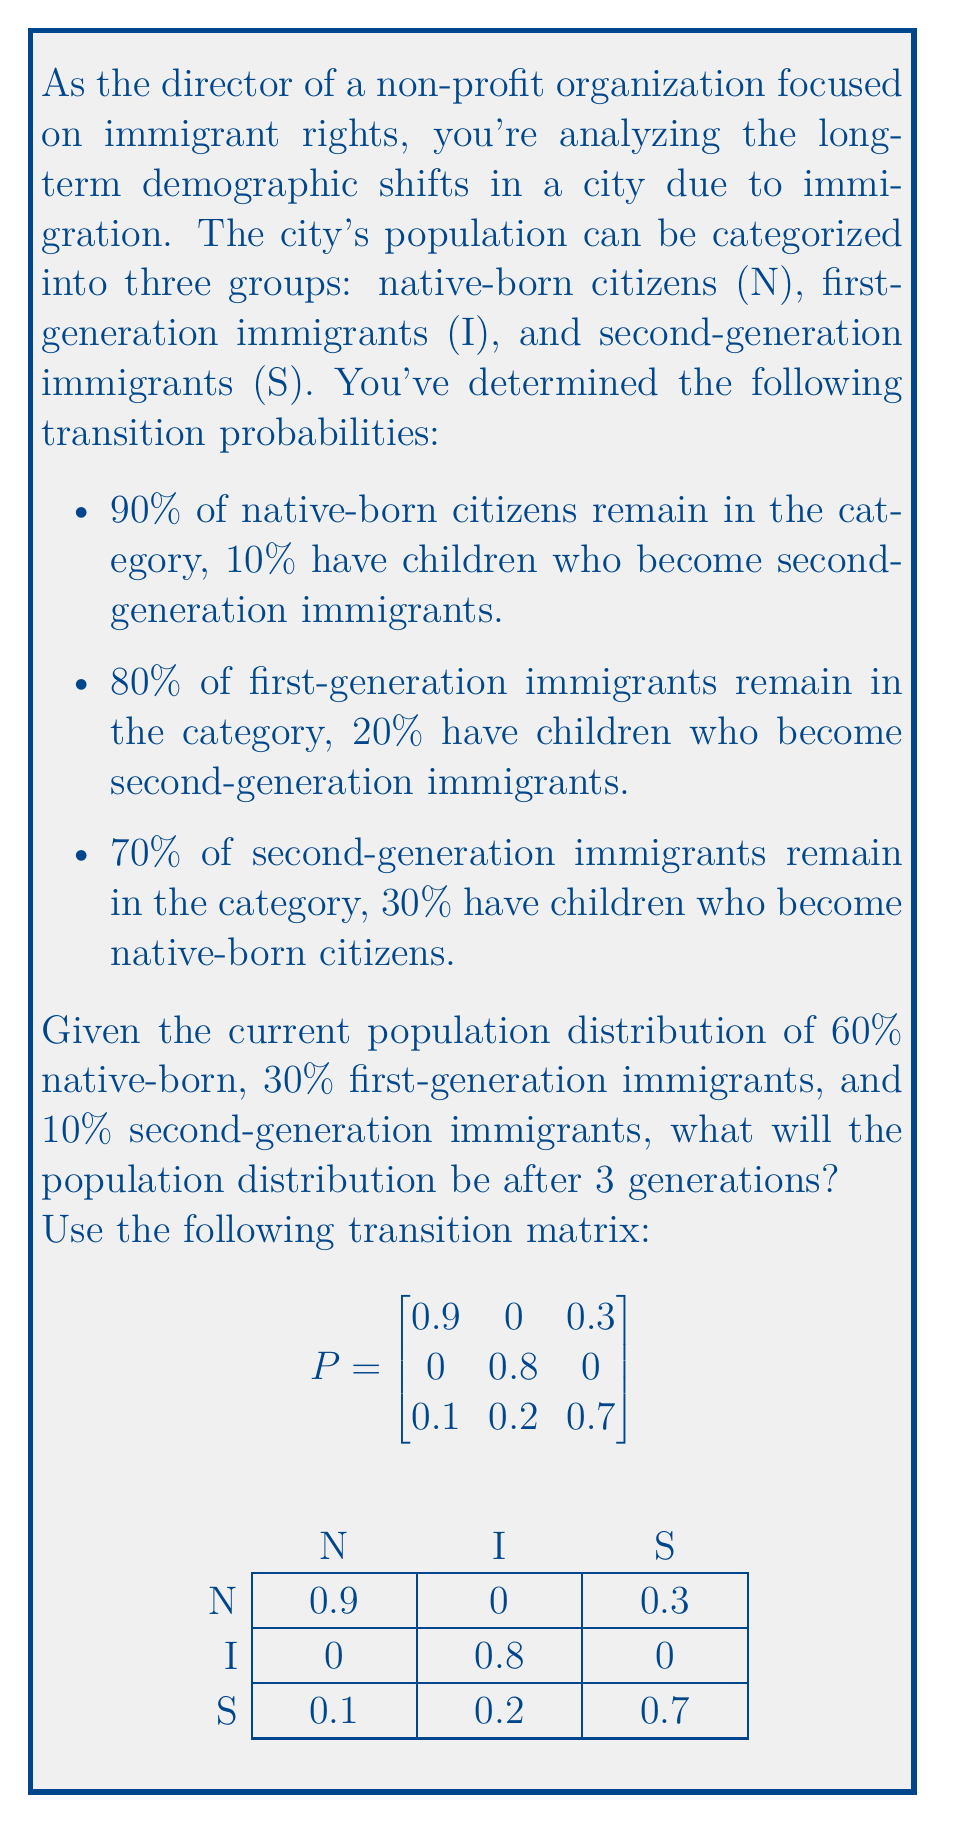Solve this math problem. To solve this problem, we'll use the Markov chain model and matrix multiplication. Let's follow these steps:

1) First, we need to represent the initial population distribution as a row vector:

   $x_0 = \begin{bmatrix} 0.6 & 0.3 & 0.1 \end{bmatrix}$

2) To find the distribution after 3 generations, we need to multiply this initial vector by the transition matrix P raised to the power of 3:

   $x_3 = x_0 \cdot P^3$

3) Let's calculate $P^3$:

   $P^2 = \begin{bmatrix}
   0.81 & 0 & 0.27 \\
   0 & 0.64 & 0 \\
   0.18 & 0.36 & 0.73
   \end{bmatrix}$

   $P^3 = \begin{bmatrix}
   0.729 & 0 & 0.243 \\
   0 & 0.512 & 0 \\
   0.243 & 0.488 & 0.757
   \end{bmatrix}$

4) Now, we can multiply $x_0$ by $P^3$:

   $x_3 = \begin{bmatrix} 0.6 & 0.3 & 0.1 \end{bmatrix} \cdot \begin{bmatrix}
   0.729 & 0 & 0.243 \\
   0 & 0.512 & 0 \\
   0.243 & 0.488 & 0.757
   \end{bmatrix}$

5) Performing the matrix multiplication:

   $x_3 = \begin{bmatrix} 0.5619 & 0.2024 & 0.2357 \end{bmatrix}$

6) Converting to percentages:

   Native-born: 56.19%
   First-generation immigrants: 20.24%
   Second-generation immigrants: 23.57%
Answer: 56.19% native-born, 20.24% first-generation immigrants, 23.57% second-generation immigrants 